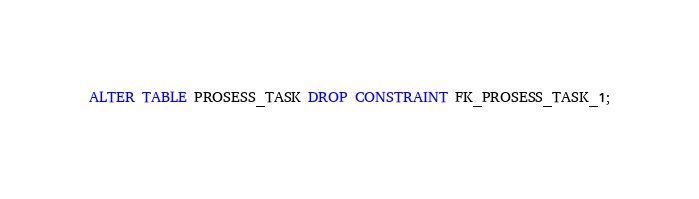<code> <loc_0><loc_0><loc_500><loc_500><_SQL_>ALTER TABLE PROSESS_TASK DROP CONSTRAINT FK_PROSESS_TASK_1;
</code> 